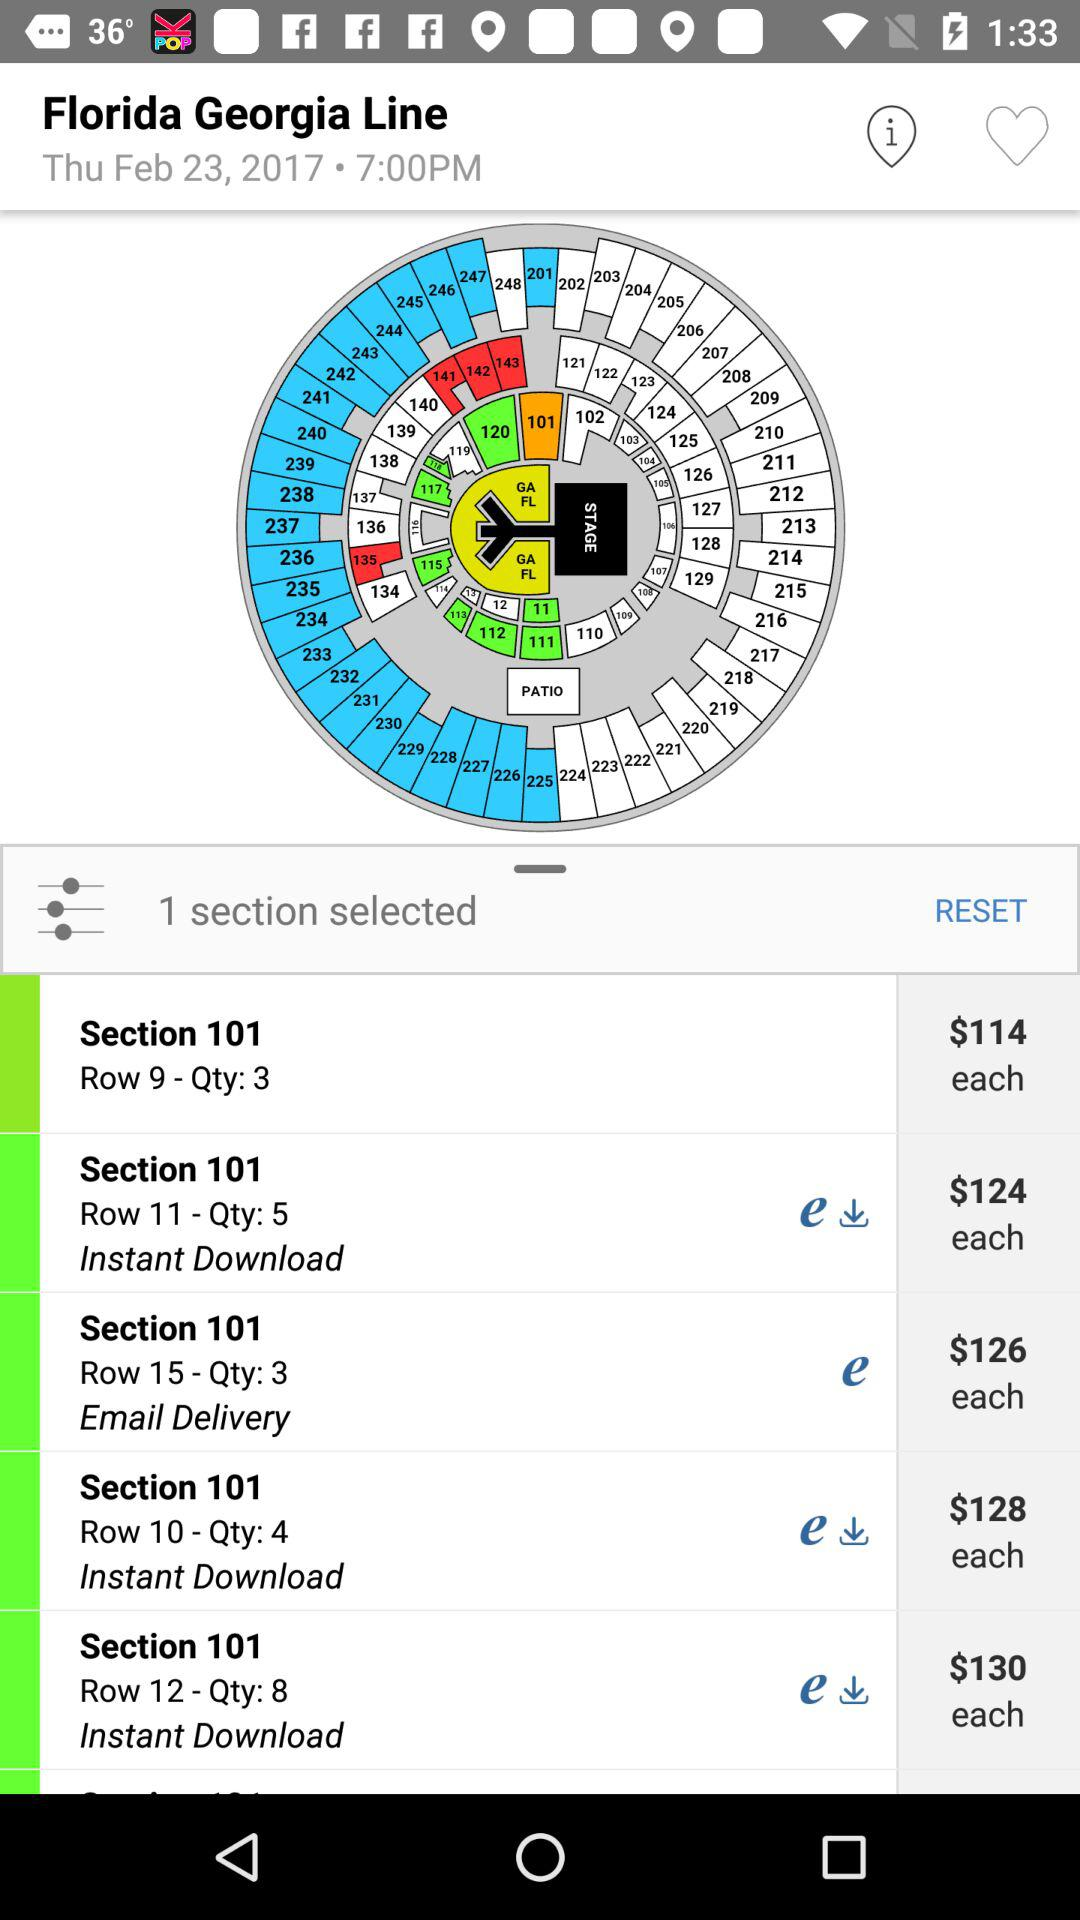What is the price per individual for row 9? The price per individual is 114 dollars for row 9. 